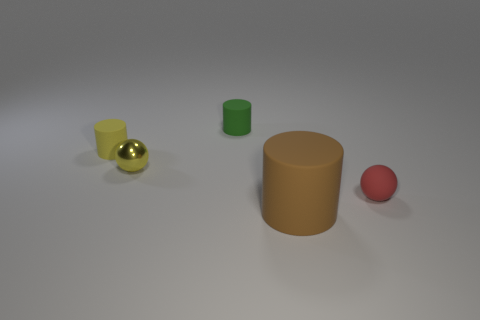Subtract all small cylinders. How many cylinders are left? 1 Add 3 small red shiny cylinders. How many objects exist? 8 Subtract all balls. How many objects are left? 3 Subtract all gray cylinders. Subtract all gray balls. How many cylinders are left? 3 Add 5 large cylinders. How many large cylinders are left? 6 Add 5 small yellow metal objects. How many small yellow metal objects exist? 6 Subtract 0 blue cylinders. How many objects are left? 5 Subtract all small green rubber cylinders. Subtract all yellow balls. How many objects are left? 3 